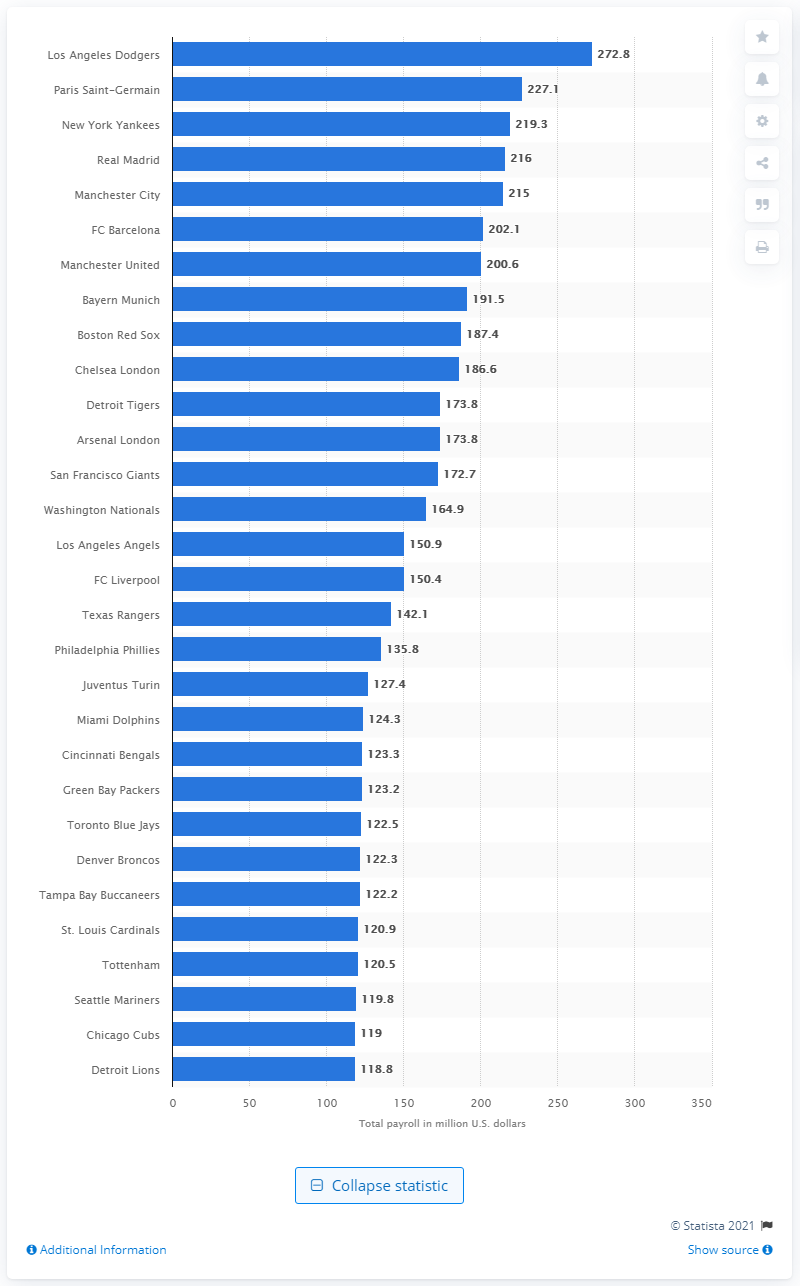Draw attention to some important aspects in this diagram. In the 2014/15 season, the Los Angeles Dodgers paid the most in player salaries. 